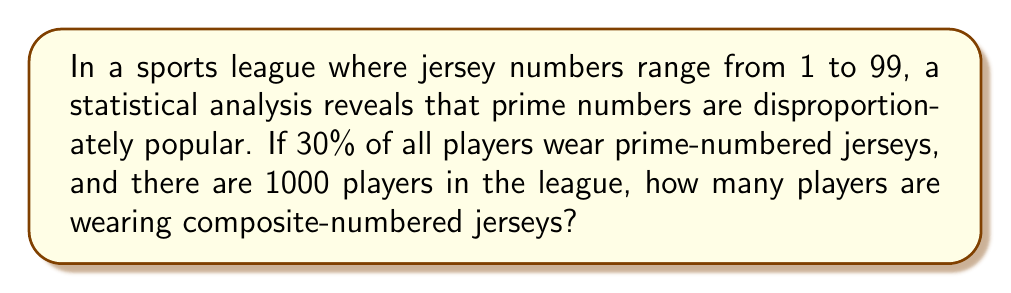Could you help me with this problem? Let's approach this step-by-step:

1) First, we need to identify how many prime numbers are in the range 1-99:
   The prime numbers from 1 to 99 are: 2, 3, 5, 7, 11, 13, 17, 19, 23, 29, 31, 37, 41, 43, 47, 53, 59, 61, 67, 71, 73, 79, 83, 89, 97
   There are 25 prime numbers in this range.

2) We're told that 30% of players wear prime-numbered jerseys. With 1000 players total:
   $$ \text{Players with prime numbers} = 1000 \times 0.30 = 300 $$

3) To find players with composite numbers, we need to subtract prime-number wearers from the total:
   $$ \text{Players with composite numbers} = 1000 - 300 = 700 $$

4) Note: This problem indirectly uses the fundamental theorem of arithmetic, which states that every integer greater than 1 is either prime or can be represented as a unique product of primes. In this context, all non-prime numbers in the range 1-99 (excluding 1) are composite.
Answer: 700 players 